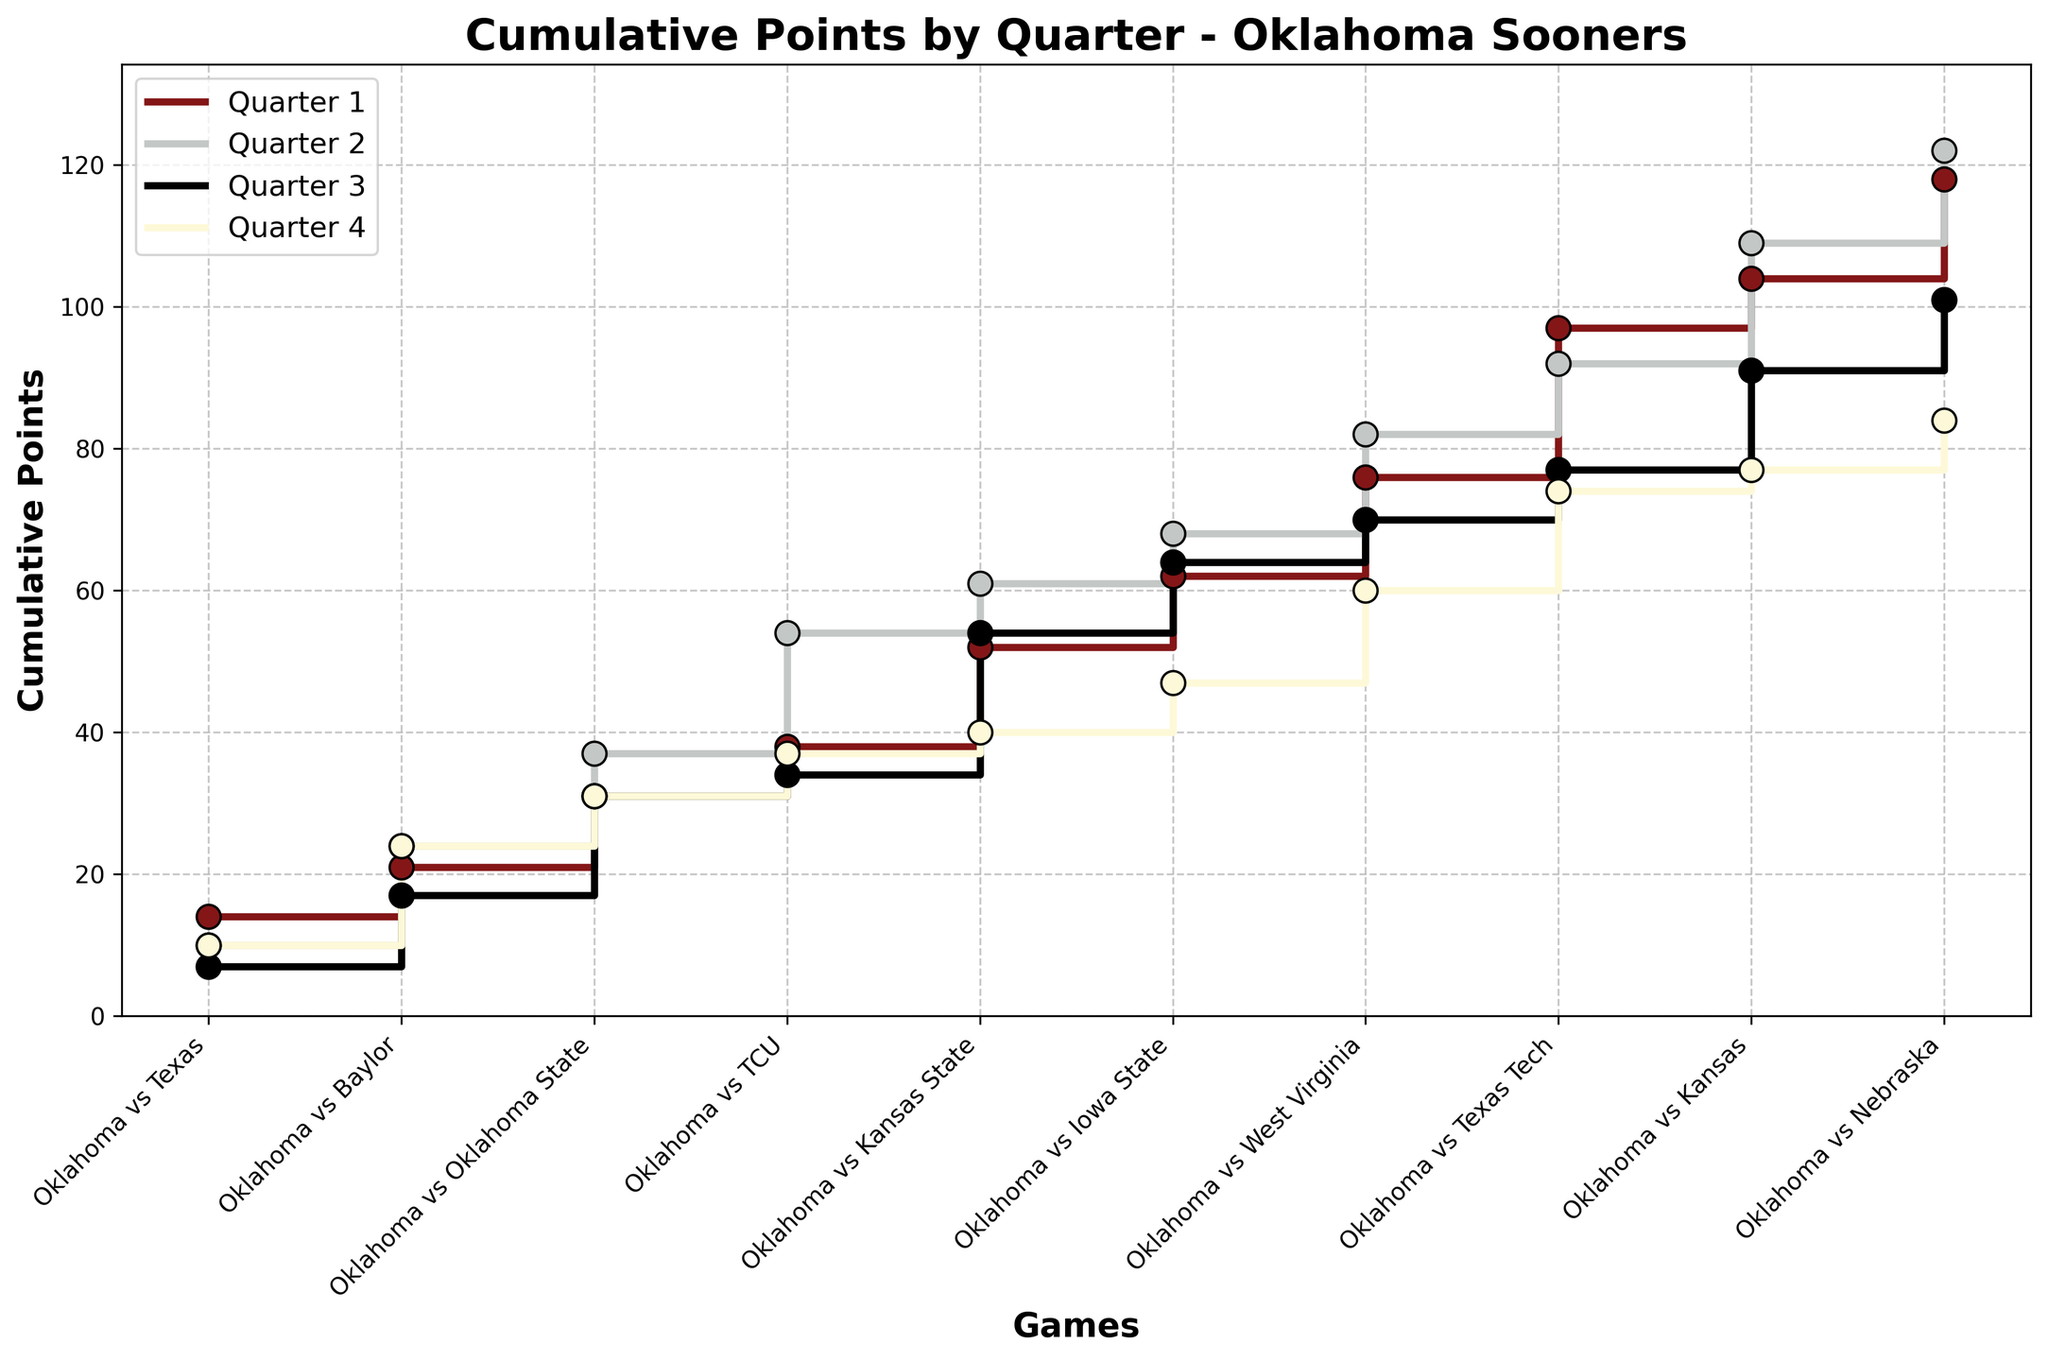What is the title of the plot? The title is usually displayed at the top of the plot and describes what the plot is about.
Answer: Cumulative Points by Quarter - Oklahoma Sooners How many games are shown in the plot? Count the number of data points or labels on the x-axis which represent the games.
Answer: 10 What is the color used to represent the points scored in Quarter 3? Identify the specific color assigned to the line and markers for Quarter 3 in the legend.
Answer: Black Which quarter has the highest cumulative points by the end of the last game? Look at the endpoints of the stair-step lines for each quarter and identify which one reaches the highest position on the y-axis.
Answer: Quarter 2 What is the total cumulative points scored by Quarter 4 in all games? Identify the endpoint of the stair-step line for Quarter 4 and note its position on the y-axis.
Answer: 84 points Which game had the highest points scored in Quarter 1? Look at the individual step heights corresponding to each game along the Quarter 1 line and find the tallest one.
Answer: Oklahoma vs Texas Tech How do the cumulative points of Quarter 1 and Quarter 4 compare by the fourth game? Find the values of the cumulative points for Quarter 1 and Quarter 4 at the position corresponding to the fourth game and compare them.
Answer: Quarter 1: 38 points, Quarter 4: 43 points In which game did the Cumulative Points for the second quarter surpass the first quarter? Track the stair-step lines for Quarter 1 and Quarter 2 and identify the first game where the Quarter 2 line is above Quarter 1.
Answer: Oklahoma vs TCU Which quarter shows the most consistent scoring pattern across all games? Look at the stair-step patterns for each quarter, the one with the smallest variations in step heights indicates the most consistency.
Answer: Quarter 3 By how many points does the cumulative score of Quarter 2 exceed Quarter 3 by the end of the tenth game? Identify the cumulative points for Quarter 2 and Quarter 3 at the end of the tenth game, then calculate the difference.
Answer: Quarter 2: 122 points, Quarter 3: 101 points; Difference: 21 points 